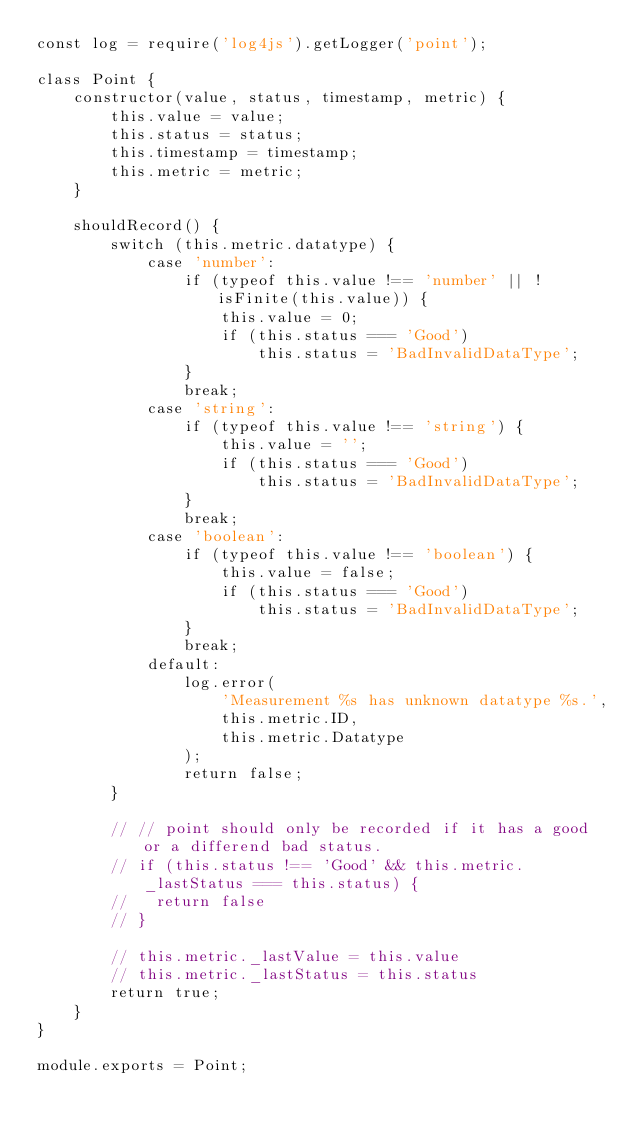Convert code to text. <code><loc_0><loc_0><loc_500><loc_500><_JavaScript_>const log = require('log4js').getLogger('point');

class Point {
    constructor(value, status, timestamp, metric) {
        this.value = value;
        this.status = status;
        this.timestamp = timestamp;
        this.metric = metric;
    }

    shouldRecord() {
        switch (this.metric.datatype) {
            case 'number':
                if (typeof this.value !== 'number' || !isFinite(this.value)) {
                    this.value = 0;
                    if (this.status === 'Good')
                        this.status = 'BadInvalidDataType';
                }
                break;
            case 'string':
                if (typeof this.value !== 'string') {
                    this.value = '';
                    if (this.status === 'Good')
                        this.status = 'BadInvalidDataType';
                }
                break;
            case 'boolean':
                if (typeof this.value !== 'boolean') {
                    this.value = false;
                    if (this.status === 'Good')
                        this.status = 'BadInvalidDataType';
                }
                break;
            default:
                log.error(
                    'Measurement %s has unknown datatype %s.',
                    this.metric.ID,
                    this.metric.Datatype
                );
                return false;
        }

        // // point should only be recorded if it has a good or a differend bad status.
        // if (this.status !== 'Good' && this.metric._lastStatus === this.status) {
        //   return false
        // }

        // this.metric._lastValue = this.value
        // this.metric._lastStatus = this.status
        return true;
    }
}

module.exports = Point;
</code> 